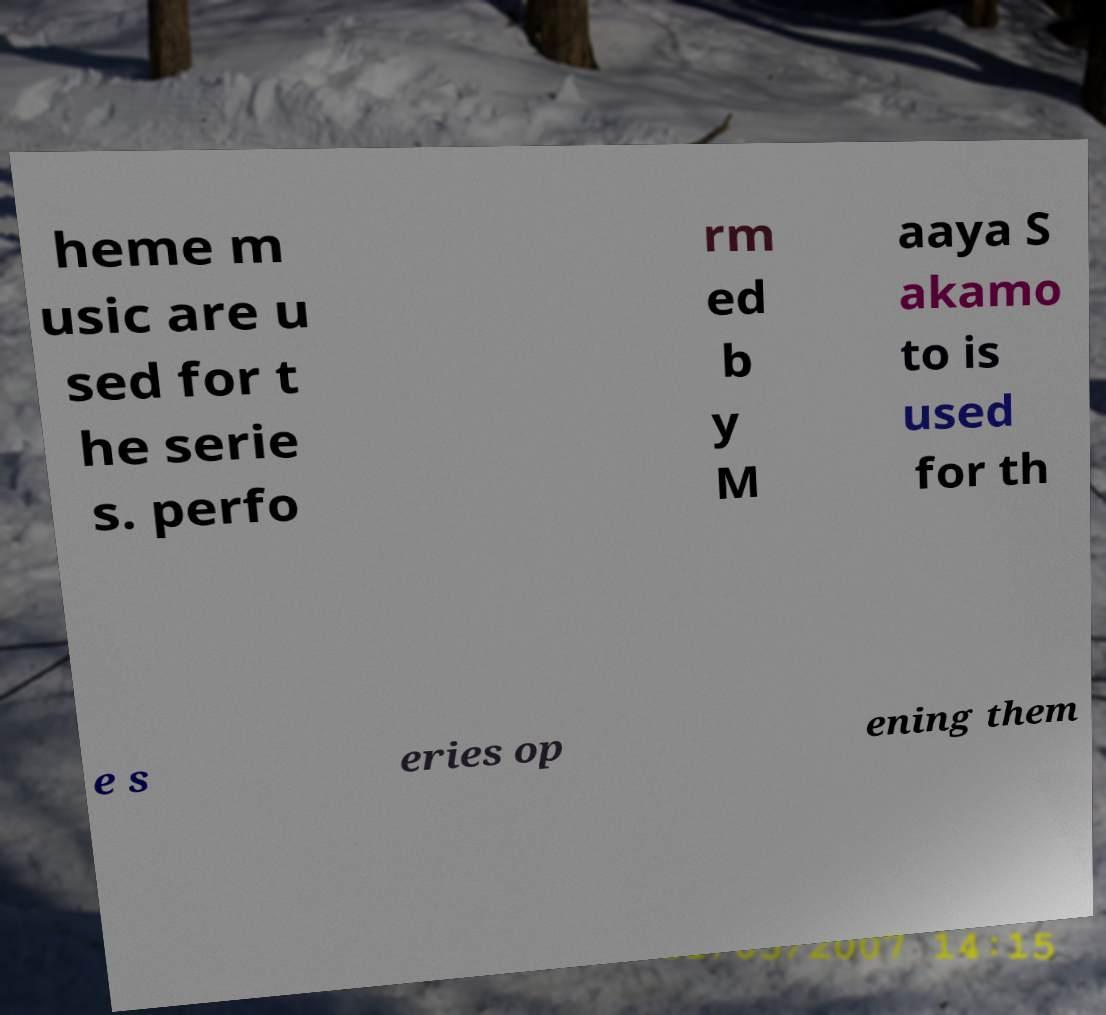For documentation purposes, I need the text within this image transcribed. Could you provide that? heme m usic are u sed for t he serie s. perfo rm ed b y M aaya S akamo to is used for th e s eries op ening them 